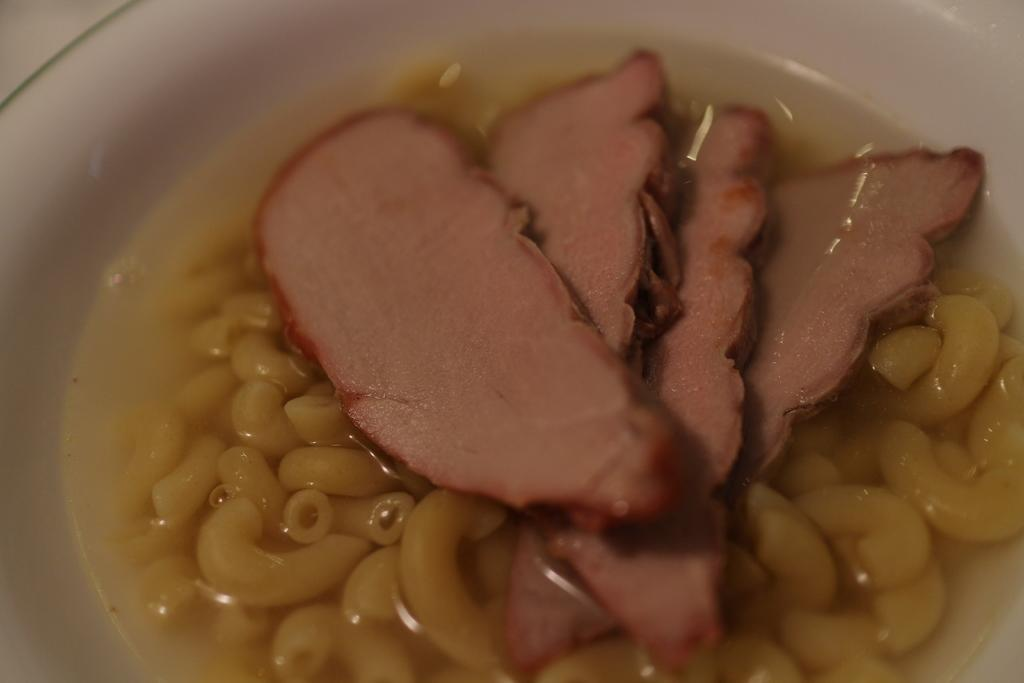What can be seen in the image in terms of food? There are different types of food in the image. Can you describe the colors of the food? The colors of the food are brown and yellow. What type of plane can be seen flying over the food in the image? There is no plane visible in the image; it only features different types of food with brown and yellow colors. 